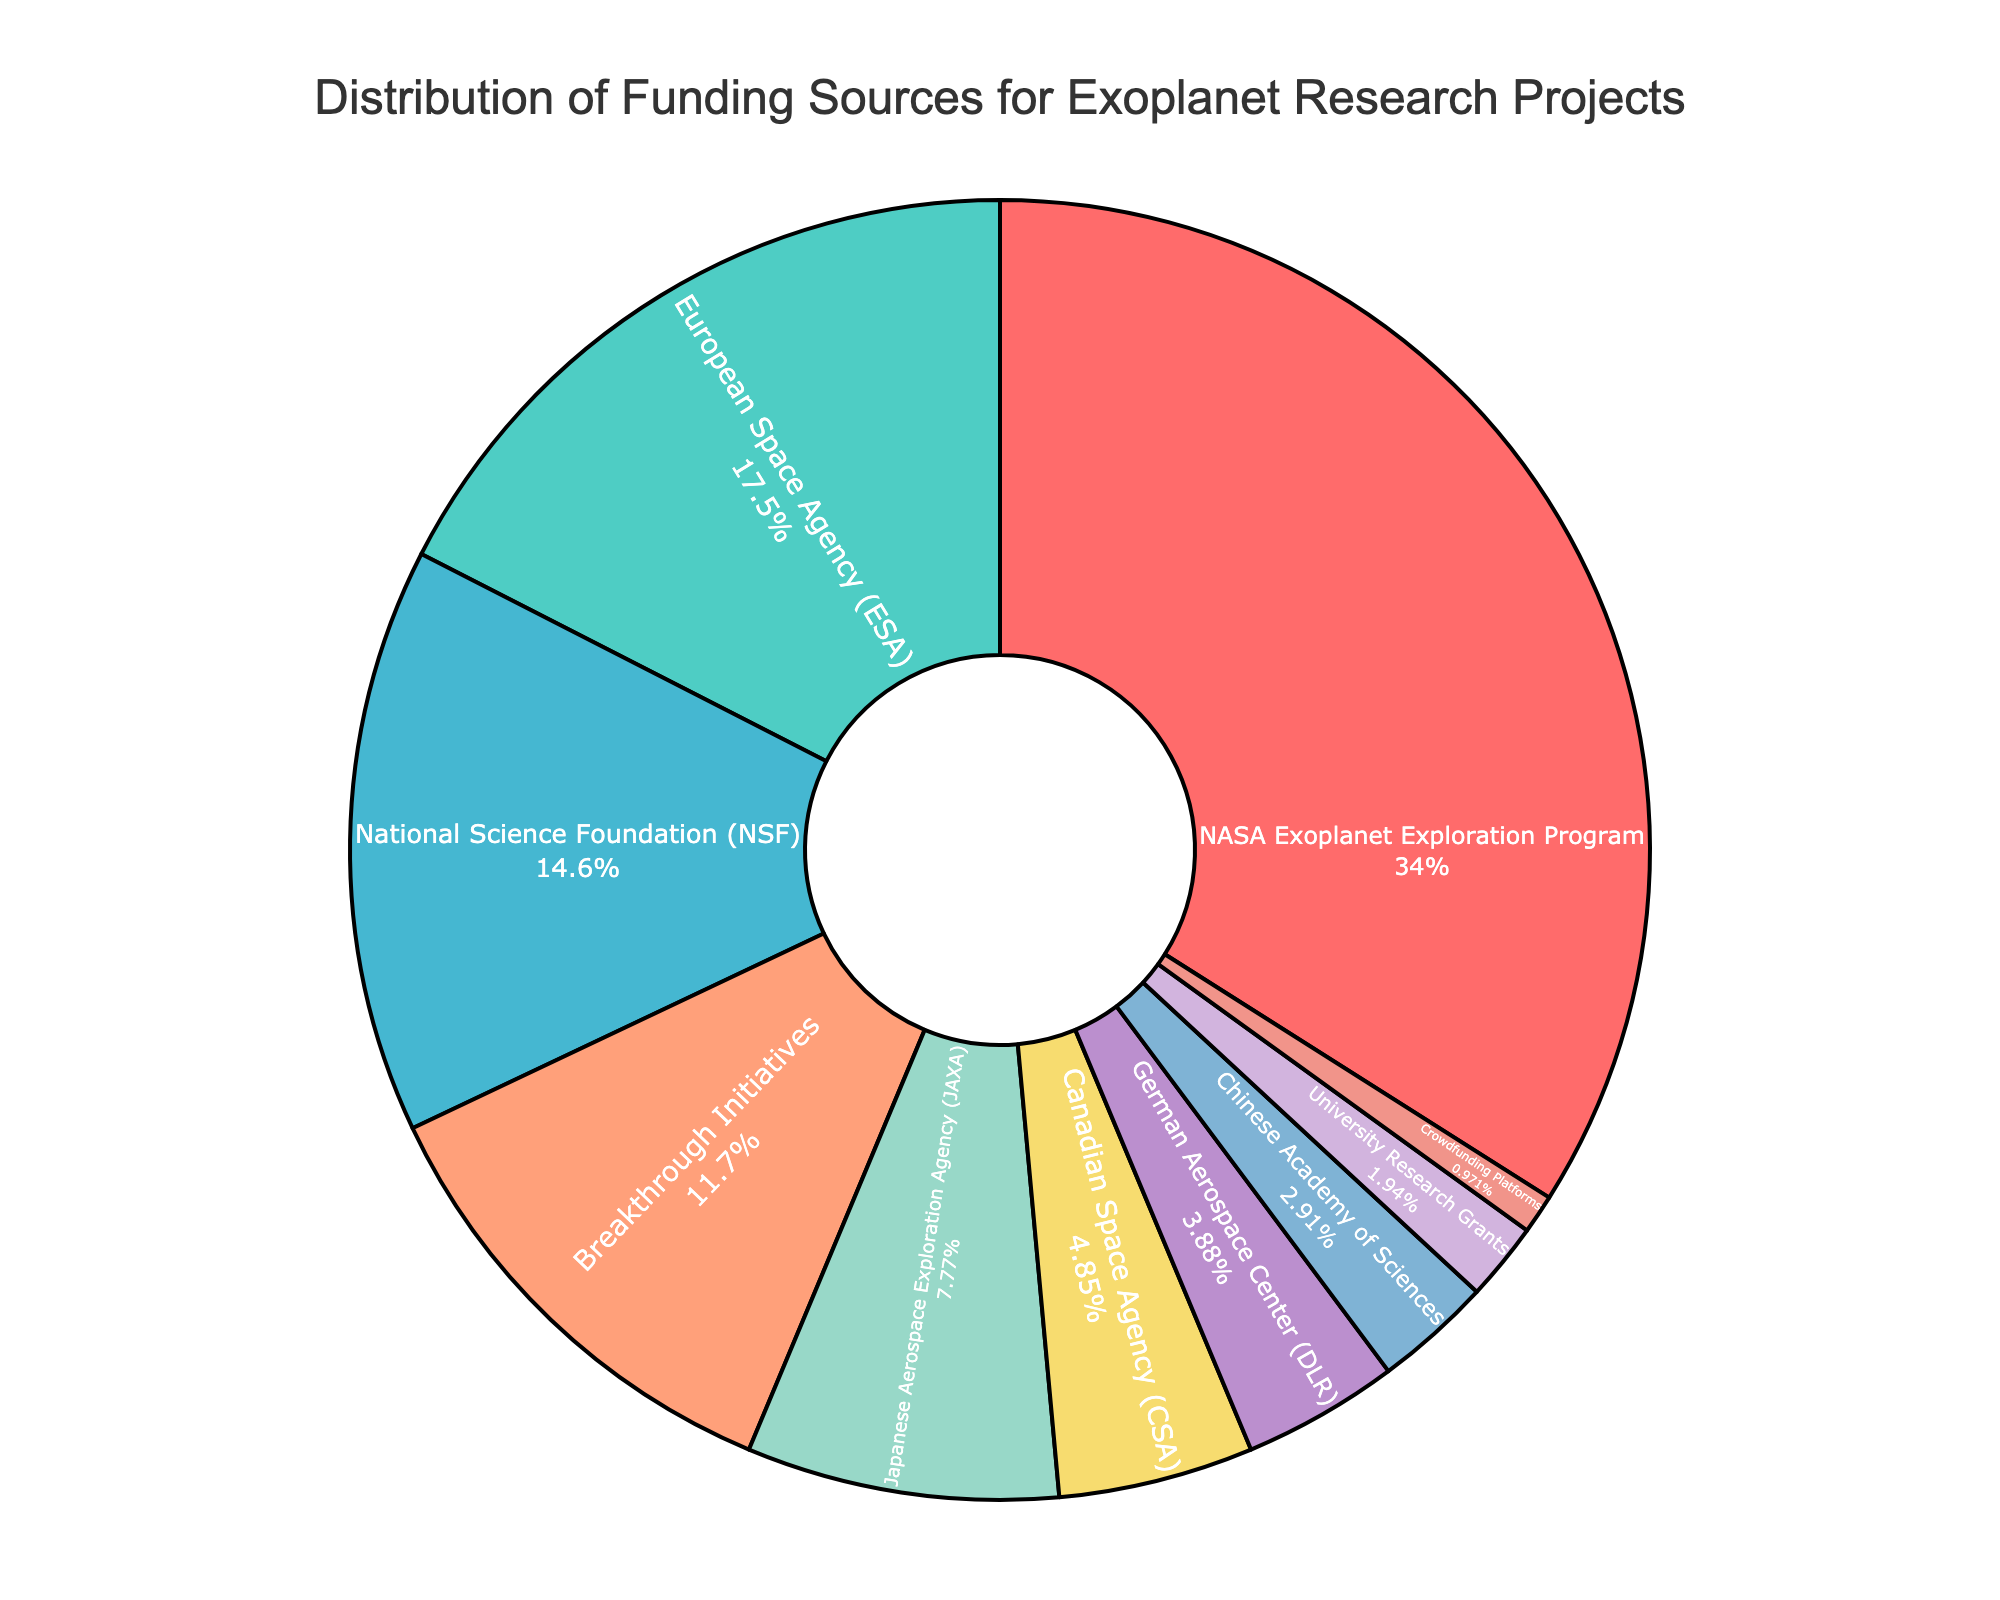Which funding source has the highest percentage? The pie chart labels and percentages show that the "NASA Exoplanet Exploration Program" has the highest percentage, which is 35%.
Answer: NASA Exoplanet Exploration Program Which is larger, the funding from the European Space Agency (ESA) or the National Science Foundation (NSF)? By comparing the percentages in the pie chart, the ESA has 18% and the NSF has 15%, thus ESA's funding is larger.
Answer: European Space Agency (ESA) What is the combined percentage of funding from Breakthrough Initiatives and Japanese Aerospace Exploration Agency (JAXA)? Summing the percentages of Breakthrough Initiatives (12%) and JAXA (8%) gives 12% + 8% = 20%.
Answer: 20% Which funding sources individually contribute less than 5% to the total funding? Examining the pie chart reveals that the Chinese Academy of Sciences (3%), University Research Grants (2%), and Crowdfunding Platforms (1%) each contribute less than 5%.
Answer: Chinese Academy of Sciences, University Research Grants, Crowdfunding Platforms How much more funding percentage does the NASA Exoplanet Exploration Program have compared to the Canadian Space Agency (CSA)? Subtracting the CSA's percentage (5%) from NASA's (35%) gives a difference of 35% - 5% = 30%.
Answer: 30% What is the total contribution of the funding sources that provide 5% or more each? Summing the percentages of NASA (35%), ESA (18%), NSF (15%), Breakthrough Initiatives (12%), and JAXA (8%) gives 35% + 18% + 15% + 12% + 8% = 88%.
Answer: 88% Is the contribution of the German Aerospace Center (DLR) greater than that of Crowdfunding Platforms? Comparing the percentages shows that DLR has 4% while Crowdfunding Platforms have 1%, so DLR's contribution is greater.
Answer: Yes 